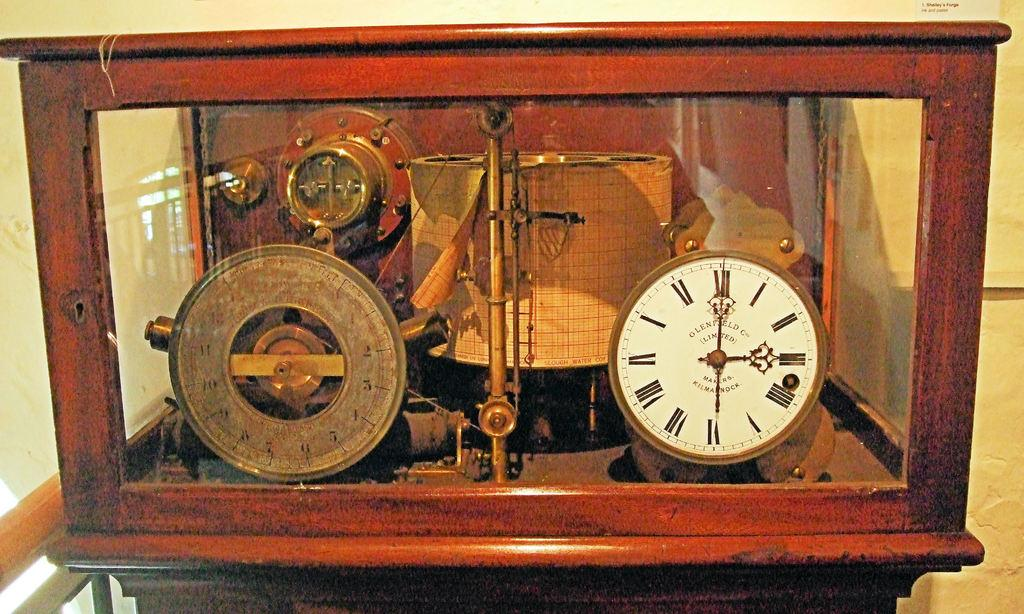<image>
Share a concise interpretation of the image provided. An old Glenfield Limited clock is displayed in a glass case and shows the time as 3:00. 